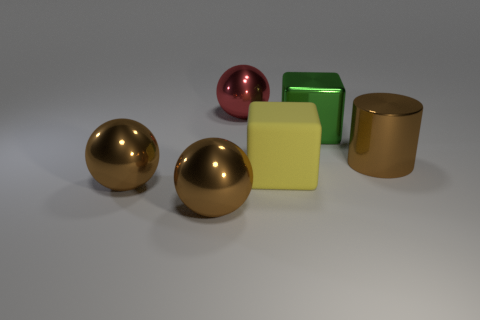Add 3 large green metallic cubes. How many objects exist? 9 Subtract all cylinders. How many objects are left? 5 Subtract 1 yellow cubes. How many objects are left? 5 Subtract all small red metal cylinders. Subtract all large red metallic balls. How many objects are left? 5 Add 5 big red metallic balls. How many big red metallic balls are left? 6 Add 5 large red metallic balls. How many large red metallic balls exist? 6 